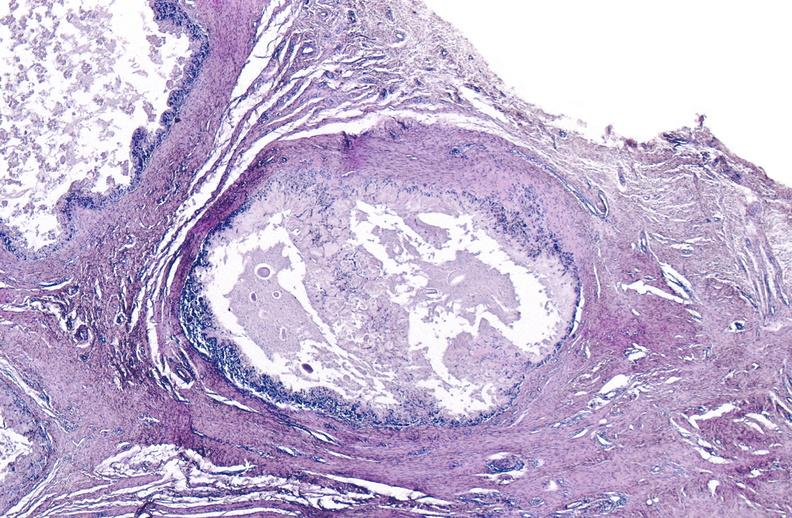does this image show gout?
Answer the question using a single word or phrase. Yes 